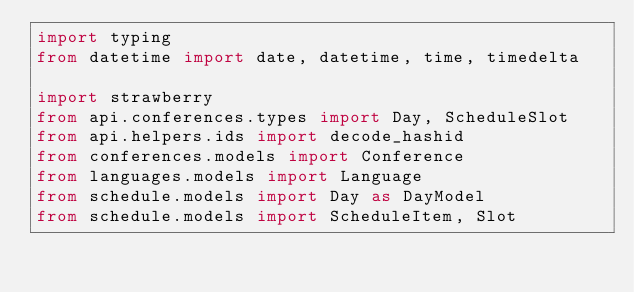<code> <loc_0><loc_0><loc_500><loc_500><_Python_>import typing
from datetime import date, datetime, time, timedelta

import strawberry
from api.conferences.types import Day, ScheduleSlot
from api.helpers.ids import decode_hashid
from conferences.models import Conference
from languages.models import Language
from schedule.models import Day as DayModel
from schedule.models import ScheduleItem, Slot
</code> 